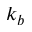Convert formula to latex. <formula><loc_0><loc_0><loc_500><loc_500>k _ { b }</formula> 